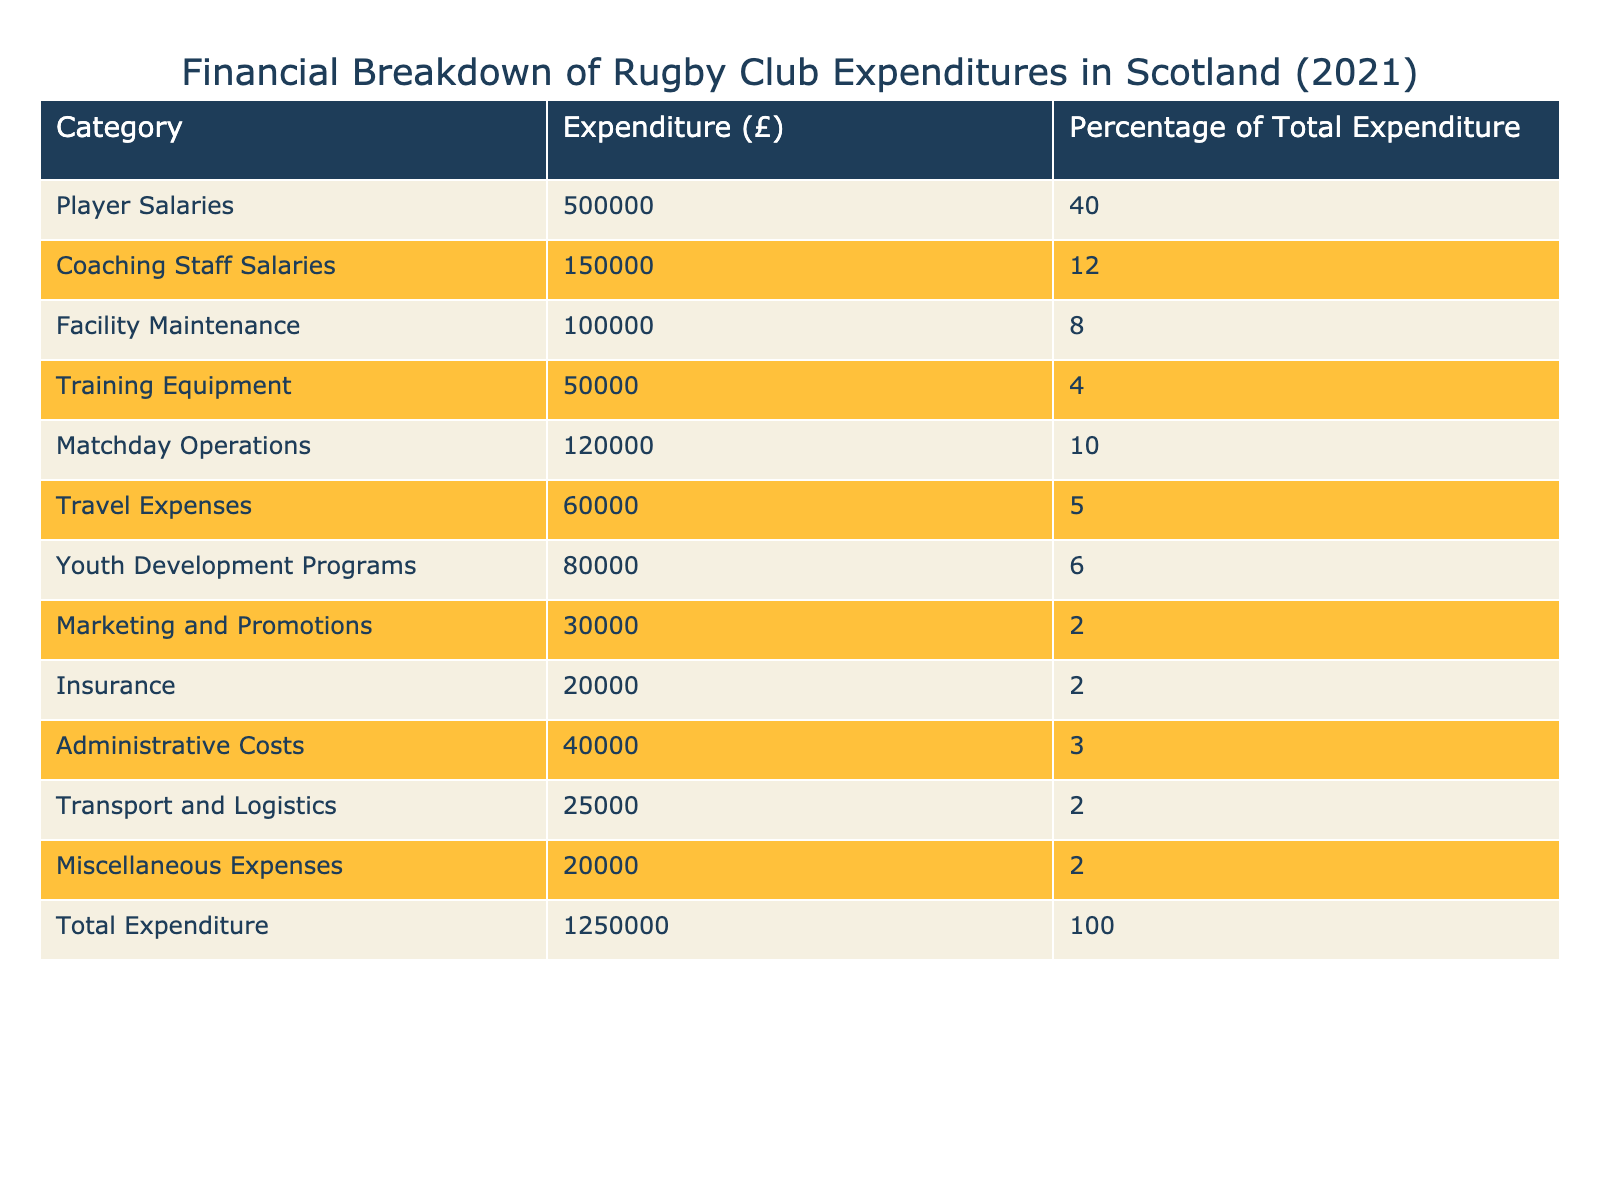What is the total expenditure for the rugby club in 2021? The total expenditure is listed in the table under the Total Expenditure category, which shows a value of £1,250,000.
Answer: £1,250,000 How much was spent on player salaries? The expenditure on player salaries is directly shown in the table under the Player Salaries category, which is £500,000.
Answer: £500,000 What percentage of total expenditure was allocated to coaching staff salaries? To find this, we look at the Coaching Staff Salaries row in the table, which shows a percentage of 12% of the total expenditure.
Answer: 12% Is the expenditure on marketing and promotions more than that on travel expenses? By comparing the values in the Marketing and Promotions category (£30,000) and the Travel Expenses category (£60,000), we see that £30,000 is less than £60,000. Thus, the statement is false.
Answer: No What is the combined total of expenditures for Youth Development Programs and Training Equipment? By adding the amounts from the two categories, Youth Development Programs (£80,000) and Training Equipment (£50,000), the combined total is £80,000 + £50,000 = £130,000.
Answer: £130,000 How much more was spent on Matchday Operations compared to Insurance? To find the difference, subtract the expenditure on Insurance (£20,000) from Matchday Operations (£120,000). Therefore, £120,000 - £20,000 = £100,000 was spent more on Matchday Operations.
Answer: £100,000 Is the total percentage of expenditures for Facility Maintenance, Training Equipment, and Administrative Costs greater than 30%? The percentages for these categories are: Facility Maintenance (8%), Training Equipment (4%), and Administrative Costs (3%). Adding these gives 8% + 4% + 3% = 15%, which is not greater than 30%. Thus, the statement is false.
Answer: No What is the average expenditure across all listed categories? To find the average, sum all the expenditures (which totals £1,250,000) and divide by the number of categories (which is 12, including Total Expenditure). The average is £1,250,000 / 12 = approximately £104,167.
Answer: £104,167 Which category had the lowest expenditure and what was the amount? In the table, the category with the lowest expenditure is Marketing and Promotions, which shows an amount of £30,000.
Answer: £30,000 